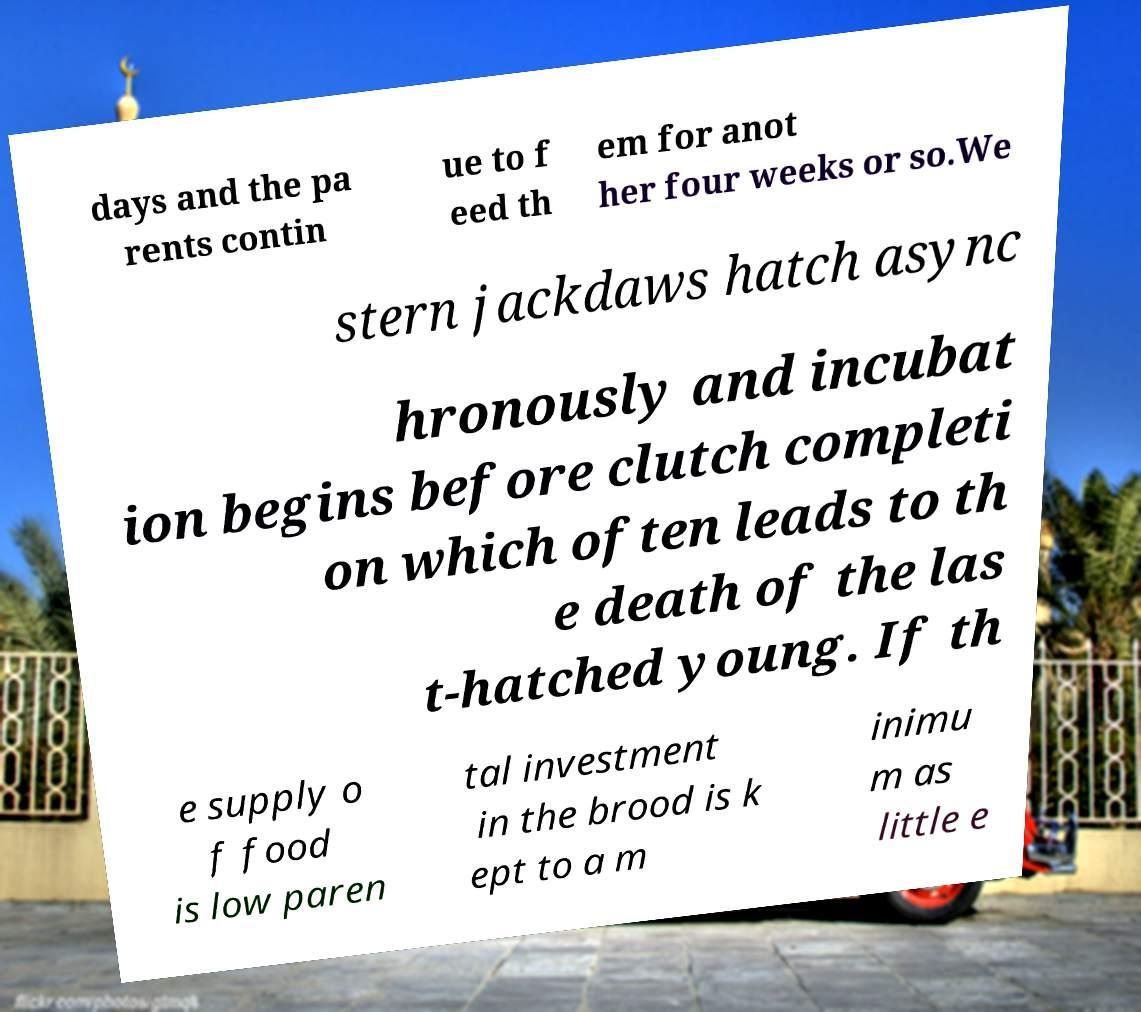There's text embedded in this image that I need extracted. Can you transcribe it verbatim? days and the pa rents contin ue to f eed th em for anot her four weeks or so.We stern jackdaws hatch async hronously and incubat ion begins before clutch completi on which often leads to th e death of the las t-hatched young. If th e supply o f food is low paren tal investment in the brood is k ept to a m inimu m as little e 